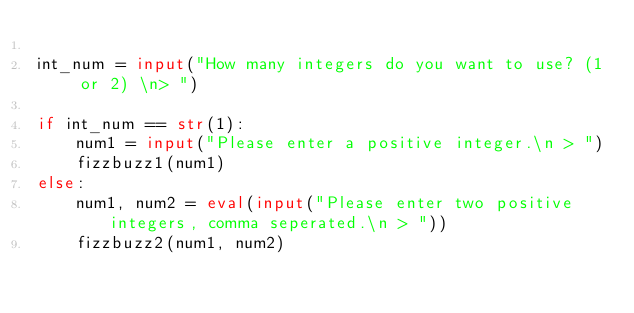Convert code to text. <code><loc_0><loc_0><loc_500><loc_500><_Python_>
int_num = input("How many integers do you want to use? (1 or 2) \n> ")

if int_num == str(1):
    num1 = input("Please enter a positive integer.\n > ")
    fizzbuzz1(num1)
else:
    num1, num2 = eval(input("Please enter two positive integers, comma seperated.\n > "))
    fizzbuzz2(num1, num2)</code> 